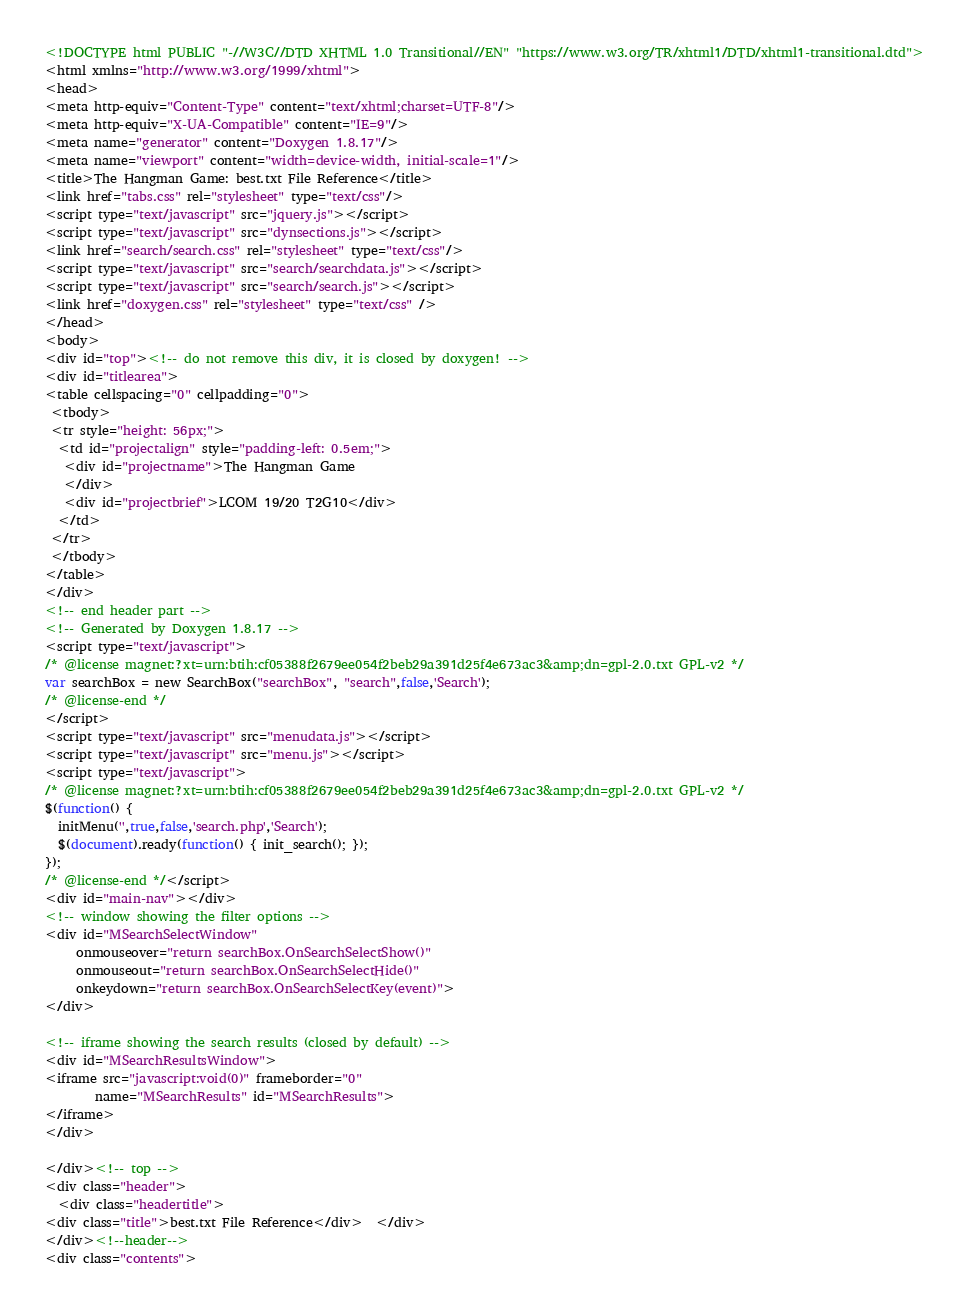Convert code to text. <code><loc_0><loc_0><loc_500><loc_500><_HTML_><!DOCTYPE html PUBLIC "-//W3C//DTD XHTML 1.0 Transitional//EN" "https://www.w3.org/TR/xhtml1/DTD/xhtml1-transitional.dtd">
<html xmlns="http://www.w3.org/1999/xhtml">
<head>
<meta http-equiv="Content-Type" content="text/xhtml;charset=UTF-8"/>
<meta http-equiv="X-UA-Compatible" content="IE=9"/>
<meta name="generator" content="Doxygen 1.8.17"/>
<meta name="viewport" content="width=device-width, initial-scale=1"/>
<title>The Hangman Game: best.txt File Reference</title>
<link href="tabs.css" rel="stylesheet" type="text/css"/>
<script type="text/javascript" src="jquery.js"></script>
<script type="text/javascript" src="dynsections.js"></script>
<link href="search/search.css" rel="stylesheet" type="text/css"/>
<script type="text/javascript" src="search/searchdata.js"></script>
<script type="text/javascript" src="search/search.js"></script>
<link href="doxygen.css" rel="stylesheet" type="text/css" />
</head>
<body>
<div id="top"><!-- do not remove this div, it is closed by doxygen! -->
<div id="titlearea">
<table cellspacing="0" cellpadding="0">
 <tbody>
 <tr style="height: 56px;">
  <td id="projectalign" style="padding-left: 0.5em;">
   <div id="projectname">The Hangman Game
   </div>
   <div id="projectbrief">LCOM 19/20 T2G10</div>
  </td>
 </tr>
 </tbody>
</table>
</div>
<!-- end header part -->
<!-- Generated by Doxygen 1.8.17 -->
<script type="text/javascript">
/* @license magnet:?xt=urn:btih:cf05388f2679ee054f2beb29a391d25f4e673ac3&amp;dn=gpl-2.0.txt GPL-v2 */
var searchBox = new SearchBox("searchBox", "search",false,'Search');
/* @license-end */
</script>
<script type="text/javascript" src="menudata.js"></script>
<script type="text/javascript" src="menu.js"></script>
<script type="text/javascript">
/* @license magnet:?xt=urn:btih:cf05388f2679ee054f2beb29a391d25f4e673ac3&amp;dn=gpl-2.0.txt GPL-v2 */
$(function() {
  initMenu('',true,false,'search.php','Search');
  $(document).ready(function() { init_search(); });
});
/* @license-end */</script>
<div id="main-nav"></div>
<!-- window showing the filter options -->
<div id="MSearchSelectWindow"
     onmouseover="return searchBox.OnSearchSelectShow()"
     onmouseout="return searchBox.OnSearchSelectHide()"
     onkeydown="return searchBox.OnSearchSelectKey(event)">
</div>

<!-- iframe showing the search results (closed by default) -->
<div id="MSearchResultsWindow">
<iframe src="javascript:void(0)" frameborder="0" 
        name="MSearchResults" id="MSearchResults">
</iframe>
</div>

</div><!-- top -->
<div class="header">
  <div class="headertitle">
<div class="title">best.txt File Reference</div>  </div>
</div><!--header-->
<div class="contents"></code> 